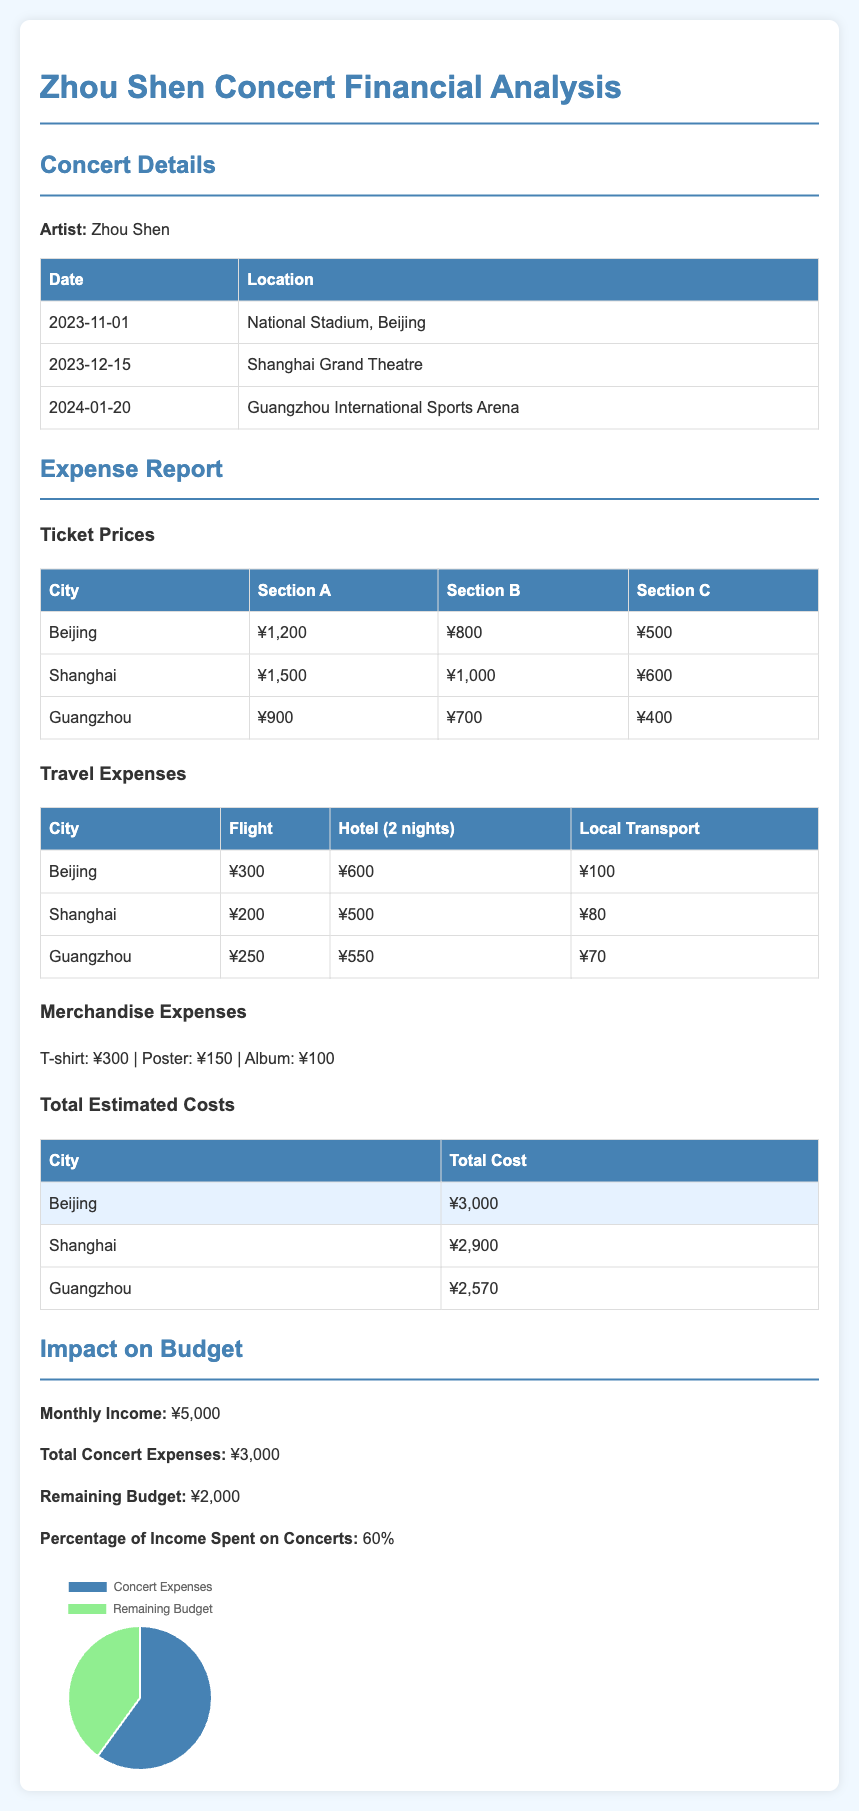What is the date of the concert in Beijing? The document states the concert in Beijing is scheduled for November 1, 2023.
Answer: November 1, 2023 What is the ticket price for Section A in Shanghai? According to the ticket prices listed, Section A in Shanghai costs ¥1,500.
Answer: ¥1,500 How much is the hotel expense for two nights in Guangzhou? The travel expenses table shows that the hotel cost for two nights in Guangzhou is ¥550.
Answer: ¥550 What is the total estimated cost for attending the concert in Beijing? The total estimated cost for attending the concert in Beijing is provided in the table as ¥3,000.
Answer: ¥3,000 What is the percentage of monthly income spent on concerts? The document specifies that 60% of the monthly income is spent on concert expenses.
Answer: 60% What is the remaining budget after attending all concerts? The impact on budget section reveals that the remaining budget is ¥2,000 after concert expenses.
Answer: ¥2,000 What is the total cost of merchandise? The document lists the costs of merchandise as T-shirt: ¥300, Poster: ¥150, Album: ¥100, totaling ¥550.
Answer: ¥550 Which city has the highest ticket price for Section B? Based on the ticket price comparison, Shanghai has the highest ticket price for Section B, which is ¥1,000.
Answer: Shanghai What is the monthly income stated in the report? The document declares the monthly income as ¥5,000.
Answer: ¥5,000 